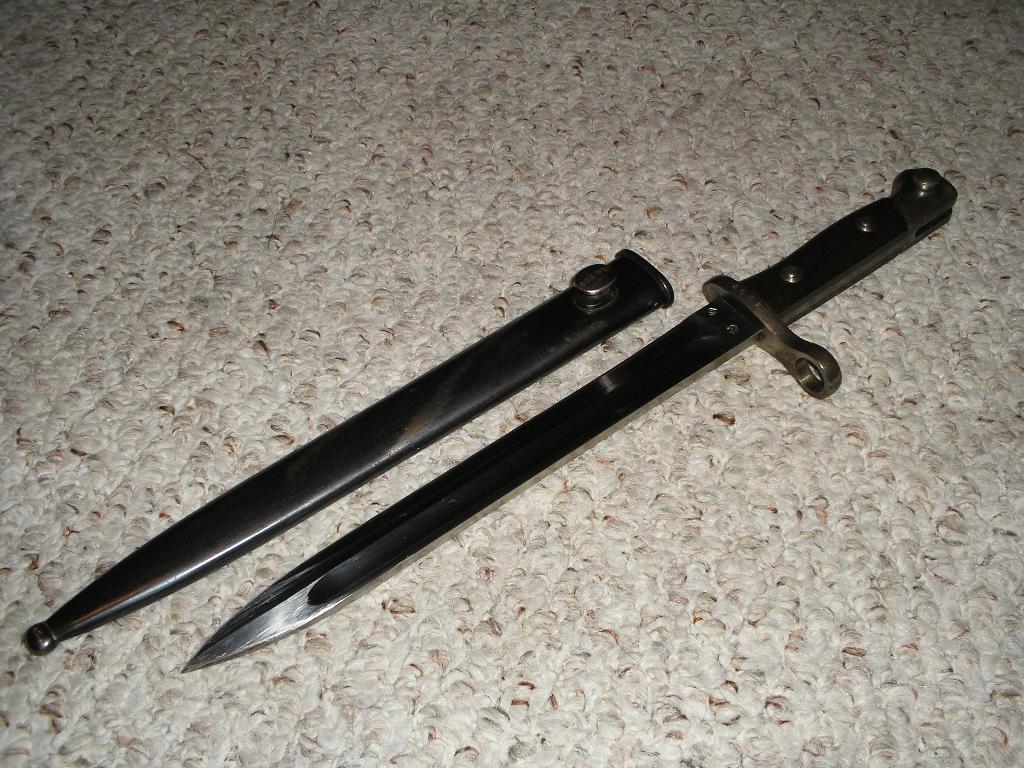In one or two sentences, can you explain what this image depicts? In the middle of this image, there is a knife and knife´s cover placed on a surface. And the background is gray in color. 